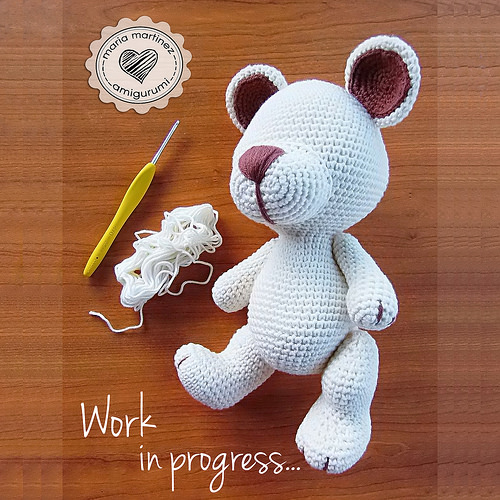<image>
Is the sticker next to the teddy bear? Yes. The sticker is positioned adjacent to the teddy bear, located nearby in the same general area. 